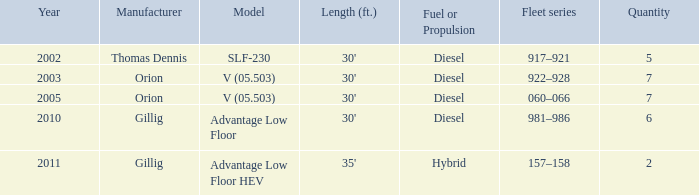Name the fleet series with a quantity of 5 917–921. 